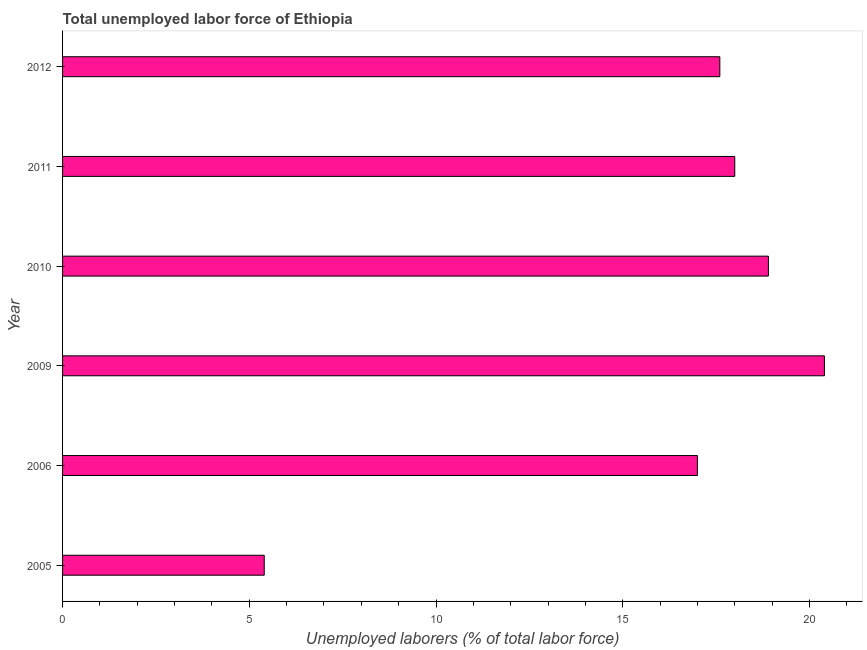Does the graph contain any zero values?
Offer a terse response. No. Does the graph contain grids?
Your answer should be very brief. No. What is the title of the graph?
Provide a succinct answer. Total unemployed labor force of Ethiopia. What is the label or title of the X-axis?
Offer a terse response. Unemployed laborers (% of total labor force). What is the total unemployed labour force in 2012?
Make the answer very short. 17.6. Across all years, what is the maximum total unemployed labour force?
Your response must be concise. 20.4. Across all years, what is the minimum total unemployed labour force?
Your response must be concise. 5.4. What is the sum of the total unemployed labour force?
Make the answer very short. 97.3. What is the average total unemployed labour force per year?
Give a very brief answer. 16.22. What is the median total unemployed labour force?
Make the answer very short. 17.8. Do a majority of the years between 2009 and 2011 (inclusive) have total unemployed labour force greater than 9 %?
Your response must be concise. Yes. What is the ratio of the total unemployed labour force in 2005 to that in 2012?
Your answer should be compact. 0.31. Is the difference between the total unemployed labour force in 2005 and 2006 greater than the difference between any two years?
Give a very brief answer. No. What is the difference between the highest and the second highest total unemployed labour force?
Keep it short and to the point. 1.5. Is the sum of the total unemployed labour force in 2010 and 2011 greater than the maximum total unemployed labour force across all years?
Offer a terse response. Yes. What is the difference between the highest and the lowest total unemployed labour force?
Offer a terse response. 15. In how many years, is the total unemployed labour force greater than the average total unemployed labour force taken over all years?
Provide a short and direct response. 5. How many bars are there?
Ensure brevity in your answer.  6. Are all the bars in the graph horizontal?
Provide a short and direct response. Yes. How many years are there in the graph?
Your response must be concise. 6. What is the difference between two consecutive major ticks on the X-axis?
Your answer should be very brief. 5. Are the values on the major ticks of X-axis written in scientific E-notation?
Offer a terse response. No. What is the Unemployed laborers (% of total labor force) in 2005?
Ensure brevity in your answer.  5.4. What is the Unemployed laborers (% of total labor force) in 2006?
Provide a succinct answer. 17. What is the Unemployed laborers (% of total labor force) of 2009?
Your response must be concise. 20.4. What is the Unemployed laborers (% of total labor force) in 2010?
Offer a very short reply. 18.9. What is the Unemployed laborers (% of total labor force) in 2012?
Give a very brief answer. 17.6. What is the difference between the Unemployed laborers (% of total labor force) in 2005 and 2006?
Ensure brevity in your answer.  -11.6. What is the difference between the Unemployed laborers (% of total labor force) in 2005 and 2009?
Keep it short and to the point. -15. What is the difference between the Unemployed laborers (% of total labor force) in 2006 and 2010?
Provide a succinct answer. -1.9. What is the difference between the Unemployed laborers (% of total labor force) in 2006 and 2011?
Provide a short and direct response. -1. What is the difference between the Unemployed laborers (% of total labor force) in 2010 and 2011?
Offer a terse response. 0.9. What is the ratio of the Unemployed laborers (% of total labor force) in 2005 to that in 2006?
Your response must be concise. 0.32. What is the ratio of the Unemployed laborers (% of total labor force) in 2005 to that in 2009?
Make the answer very short. 0.27. What is the ratio of the Unemployed laborers (% of total labor force) in 2005 to that in 2010?
Keep it short and to the point. 0.29. What is the ratio of the Unemployed laborers (% of total labor force) in 2005 to that in 2011?
Provide a succinct answer. 0.3. What is the ratio of the Unemployed laborers (% of total labor force) in 2005 to that in 2012?
Ensure brevity in your answer.  0.31. What is the ratio of the Unemployed laborers (% of total labor force) in 2006 to that in 2009?
Give a very brief answer. 0.83. What is the ratio of the Unemployed laborers (% of total labor force) in 2006 to that in 2010?
Your answer should be very brief. 0.9. What is the ratio of the Unemployed laborers (% of total labor force) in 2006 to that in 2011?
Provide a succinct answer. 0.94. What is the ratio of the Unemployed laborers (% of total labor force) in 2009 to that in 2010?
Provide a short and direct response. 1.08. What is the ratio of the Unemployed laborers (% of total labor force) in 2009 to that in 2011?
Offer a terse response. 1.13. What is the ratio of the Unemployed laborers (% of total labor force) in 2009 to that in 2012?
Offer a terse response. 1.16. What is the ratio of the Unemployed laborers (% of total labor force) in 2010 to that in 2012?
Your response must be concise. 1.07. What is the ratio of the Unemployed laborers (% of total labor force) in 2011 to that in 2012?
Offer a very short reply. 1.02. 